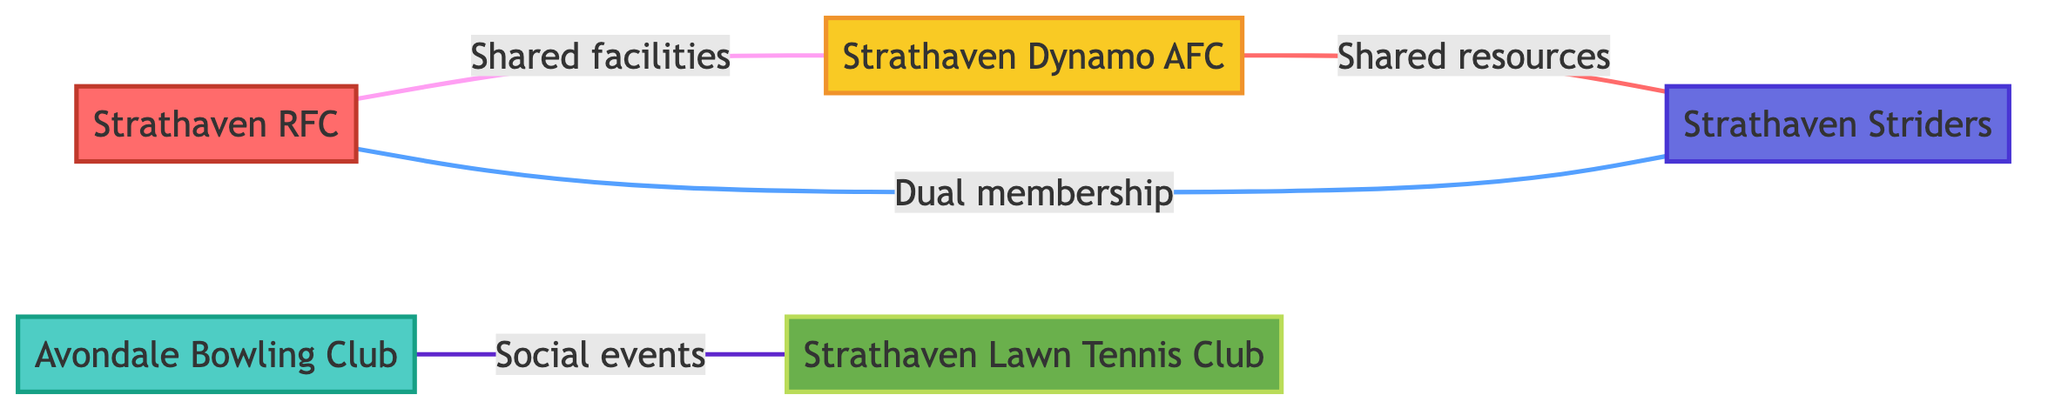What is the total number of sports clubs represented in the diagram? The diagram includes five distinct nodes, each representing a different sports club.
Answer: 5 Which two clubs have a dual membership relationship? The edge labeled "Dual membership" connects Strathaven RFC and Strathaven Striders, indicating that several members participate in both clubs.
Answer: Strathaven RFC and Strathaven Striders How many different types of sports clubs are showcased in the diagram? The diagram presents clubs from five categories: Rugby, Bowling, Football, Tennis, and Running, indicating five types.
Answer: 5 What relationship exists between Avondale Bowling Club and Strathaven Lawn Tennis Club? The edge labeled "Social events" shows that these clubs collaborate on joint social events to enhance community engagement.
Answer: Social events Which sports clubs share facilities? The edge labeled "Shared facilities" shows that Strathaven RFC and Strathaven Dynamo AFC both utilize the town's main sports field for their training sessions.
Answer: Strathaven RFC and Strathaven Dynamo AFC What is the relationship between Strathaven Dynamo AFC and Strathaven Striders? The edge labeled "Shared resources" indicates that these two sports clubs have a partnership aimed at promoting fitness and sports among youths.
Answer: Shared resources Which club focuses on competitive tennis? Strathaven Lawn Tennis Club, as described in the node, emphasizes both social interaction and competitive aspects of tennis.
Answer: Strathaven Lawn Tennis Club How many shared relationships are illustrated in the diagram? The diagram depicts four edges representing different relationships, thus indicating four shared relationships among the clubs.
Answer: 4 What type of activities does Strathaven Striders host? The description for Strathaven Striders notes that it is a community running club that organizes weekly runs and events.
Answer: Weekly runs and events Which club is affiliated with youth and senior teams in rugby? The node description for Strathaven RFC highlights that it is a local rugby club offering youth and senior teams.
Answer: Strathaven RFC 